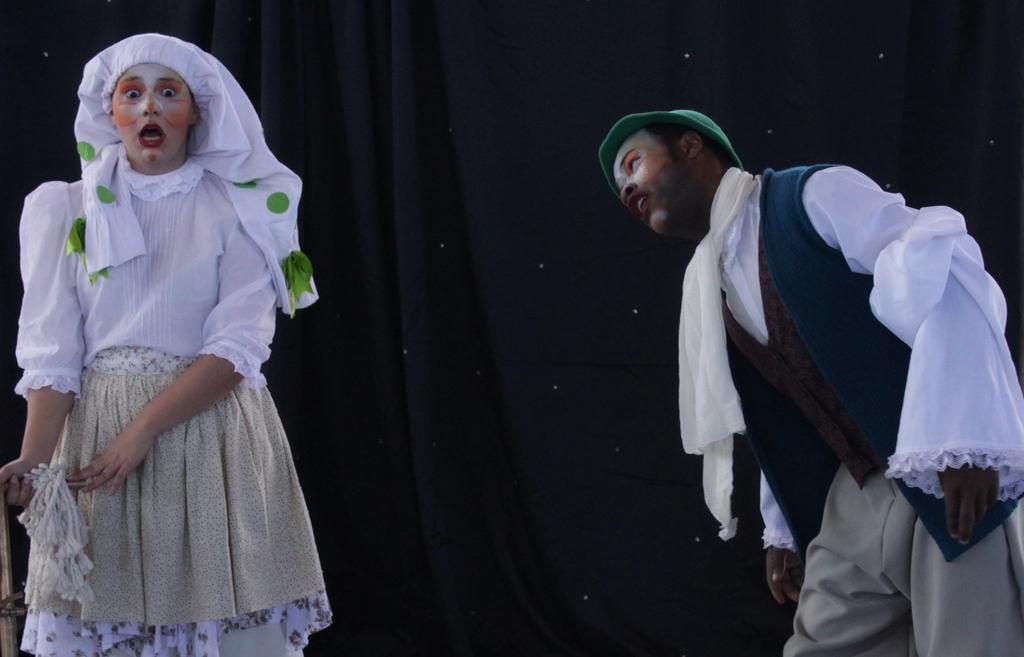Who can be seen in the image? There is a lady and a man in the image. What are the lady and the man wearing? Both the lady and the man are wearing costumes. Can you describe their appearance further? They both have makeup on. What else is visible in the image? There is a curtain visible in the image. How many rabbits can be seen in the image? There are no rabbits present in the image. What rule is being broken by the lady and the man in the image? There is no indication of any rule being broken in the image. 